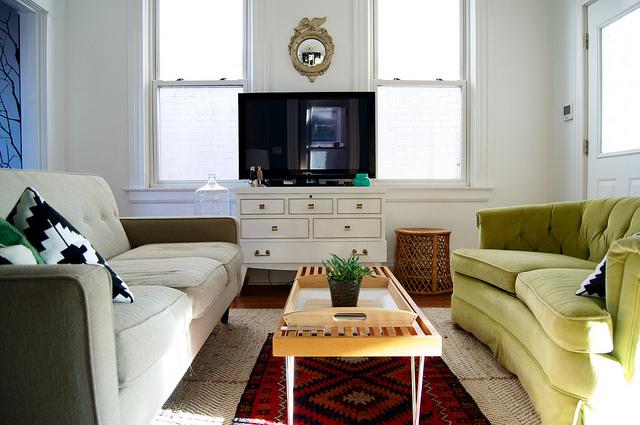What is made of wicker?
Concise answer only. Basket. What is on the coffee table?
Give a very brief answer. Plant. What is on both sides of the TV set?
Give a very brief answer. Windows. 